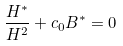<formula> <loc_0><loc_0><loc_500><loc_500>\frac { H ^ { \ast } } { H ^ { 2 } } + c _ { 0 } B ^ { \ast } = 0</formula> 